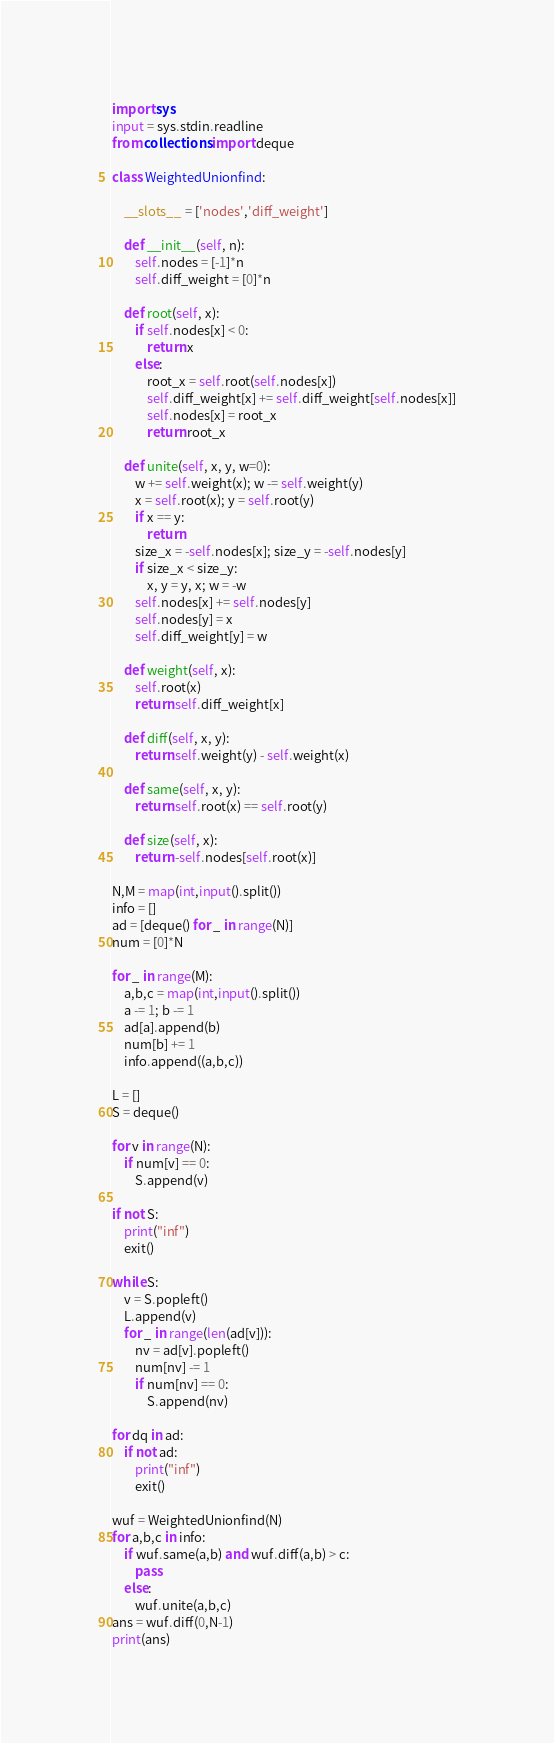Convert code to text. <code><loc_0><loc_0><loc_500><loc_500><_Python_>import sys
input = sys.stdin.readline
from collections import deque

class WeightedUnionfind:

    __slots__ = ['nodes','diff_weight']

    def __init__(self, n):
        self.nodes = [-1]*n
        self.diff_weight = [0]*n

    def root(self, x):
        if self.nodes[x] < 0:
            return x
        else:
            root_x = self.root(self.nodes[x])
            self.diff_weight[x] += self.diff_weight[self.nodes[x]]
            self.nodes[x] = root_x
            return root_x

    def unite(self, x, y, w=0):
        w += self.weight(x); w -= self.weight(y)
        x = self.root(x); y = self.root(y)
        if x == y:
            return
        size_x = -self.nodes[x]; size_y = -self.nodes[y]
        if size_x < size_y:
            x, y = y, x; w = -w
        self.nodes[x] += self.nodes[y]
        self.nodes[y] = x
        self.diff_weight[y] = w

    def weight(self, x):
        self.root(x)
        return self.diff_weight[x]

    def diff(self, x, y):
        return self.weight(y) - self.weight(x)

    def same(self, x, y):
        return self.root(x) == self.root(y)

    def size(self, x):
        return -self.nodes[self.root(x)]

N,M = map(int,input().split())
info = []
ad = [deque() for _ in range(N)]
num = [0]*N

for _ in range(M):
    a,b,c = map(int,input().split())
    a -= 1; b -= 1
    ad[a].append(b)
    num[b] += 1
    info.append((a,b,c))

L = []
S = deque()

for v in range(N):
    if num[v] == 0:
        S.append(v)

if not S:
    print("inf")
    exit()

while S:
    v = S.popleft()
    L.append(v)
    for _ in range(len(ad[v])):
        nv = ad[v].popleft()
        num[nv] -= 1
        if num[nv] == 0:
            S.append(nv)

for dq in ad:
    if not ad:
        print("inf")
        exit()

wuf = WeightedUnionfind(N)
for a,b,c in info:
    if wuf.same(a,b) and wuf.diff(a,b) > c:
        pass
    else:
        wuf.unite(a,b,c)
ans = wuf.diff(0,N-1)
print(ans)</code> 